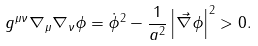Convert formula to latex. <formula><loc_0><loc_0><loc_500><loc_500>g ^ { \mu \nu } \nabla _ { \mu } \nabla _ { \nu } \phi = \dot { \phi } ^ { 2 } - \frac { 1 } { a ^ { 2 } } \left | \vec { \nabla } \phi \right | ^ { 2 } > 0 .</formula> 